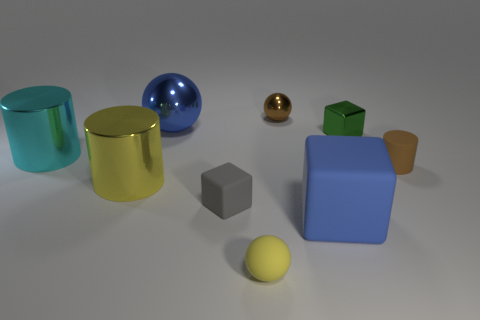There is a big cylinder that is right of the cyan metallic object that is on the left side of the brown matte thing in front of the big blue metal thing; what color is it?
Provide a short and direct response. Yellow. The small rubber cylinder has what color?
Keep it short and to the point. Brown. Are there more small metal spheres on the left side of the blue metallic thing than big metal spheres right of the small brown rubber object?
Your answer should be very brief. No. Do the gray matte thing and the rubber object behind the gray cube have the same shape?
Offer a terse response. No. Do the cube that is left of the small metallic ball and the brown thing in front of the tiny shiny ball have the same size?
Give a very brief answer. Yes. Is there a large metal object behind the rubber object that is right of the blue object in front of the big cyan thing?
Your answer should be compact. Yes. Is the number of tiny gray things behind the small yellow matte object less than the number of tiny balls that are to the left of the large yellow object?
Make the answer very short. No. There is a big cyan thing that is the same material as the big blue sphere; what is its shape?
Offer a terse response. Cylinder. What size is the blue thing that is on the right side of the big blue thing left of the tiny thing that is behind the blue shiny thing?
Offer a terse response. Large. Are there more small brown metallic things than purple objects?
Keep it short and to the point. Yes. 